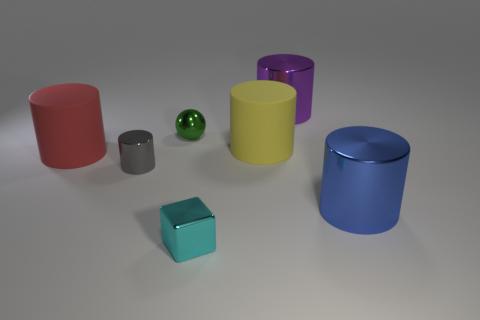Subtract all blue metallic cylinders. How many cylinders are left? 4 Subtract all yellow cylinders. How many cylinders are left? 4 Subtract all red cylinders. Subtract all gray spheres. How many cylinders are left? 4 Add 1 matte things. How many objects exist? 8 Subtract all cubes. How many objects are left? 6 Subtract 0 cyan cylinders. How many objects are left? 7 Subtract all gray things. Subtract all large purple balls. How many objects are left? 6 Add 3 large red cylinders. How many large red cylinders are left? 4 Add 2 small green shiny cylinders. How many small green shiny cylinders exist? 2 